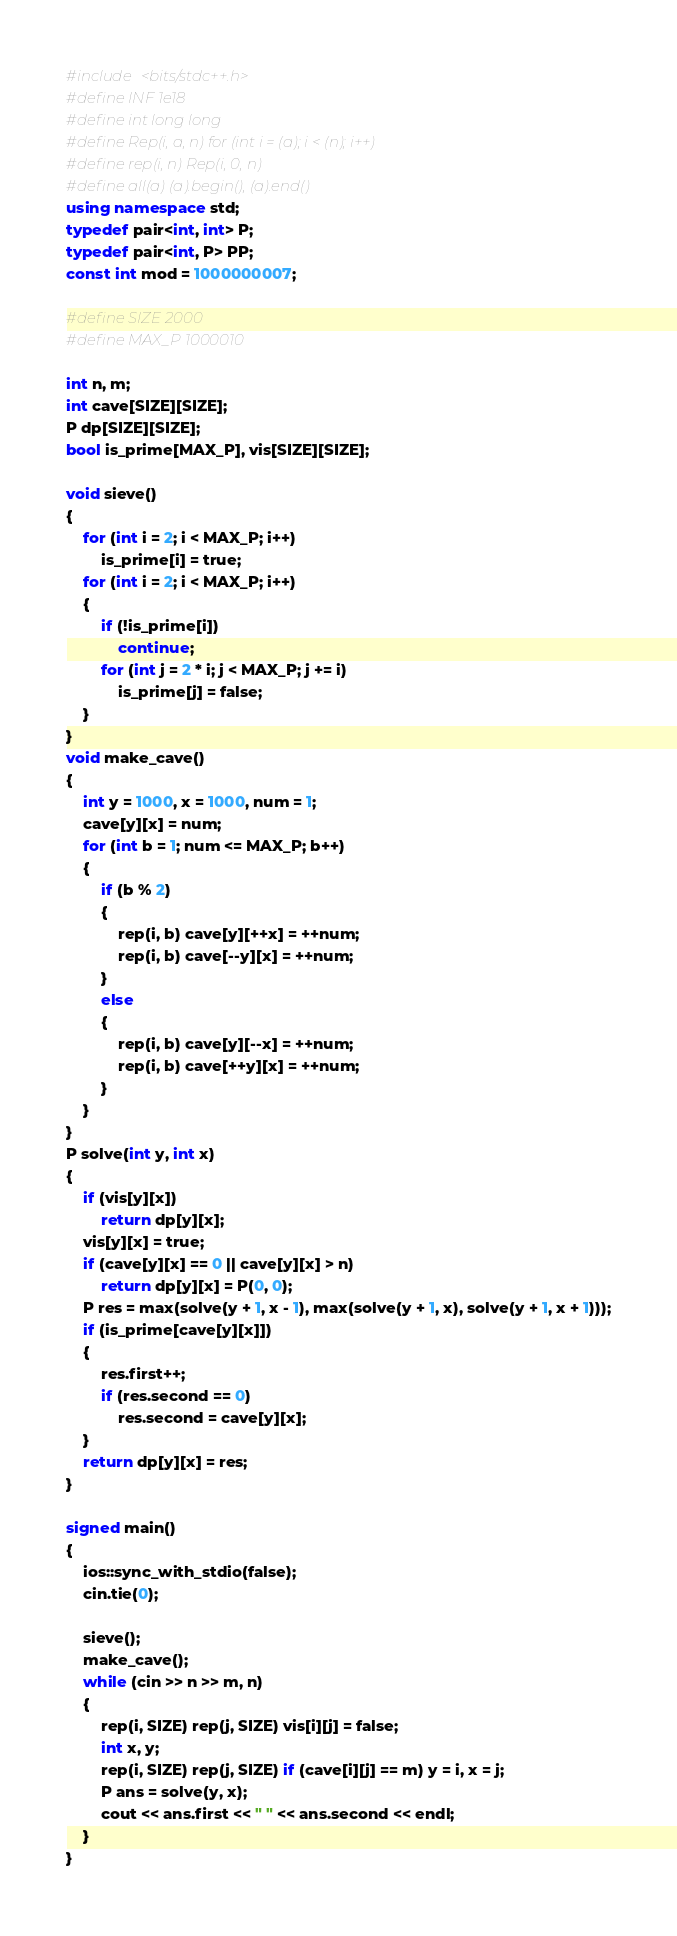Convert code to text. <code><loc_0><loc_0><loc_500><loc_500><_C++_>#include <bits/stdc++.h>
#define INF 1e18
#define int long long
#define Rep(i, a, n) for (int i = (a); i < (n); i++)
#define rep(i, n) Rep(i, 0, n)
#define all(a) (a).begin(), (a).end()
using namespace std;
typedef pair<int, int> P;
typedef pair<int, P> PP;
const int mod = 1000000007;

#define SIZE 2000
#define MAX_P 1000010

int n, m;
int cave[SIZE][SIZE];
P dp[SIZE][SIZE];
bool is_prime[MAX_P], vis[SIZE][SIZE];

void sieve()
{
    for (int i = 2; i < MAX_P; i++)
        is_prime[i] = true;
    for (int i = 2; i < MAX_P; i++)
    {
        if (!is_prime[i])
            continue;
        for (int j = 2 * i; j < MAX_P; j += i)
            is_prime[j] = false;
    }
}
void make_cave()
{
    int y = 1000, x = 1000, num = 1;
    cave[y][x] = num;
    for (int b = 1; num <= MAX_P; b++)
    {
        if (b % 2)
        {
            rep(i, b) cave[y][++x] = ++num;
            rep(i, b) cave[--y][x] = ++num;
        }
        else
        {
            rep(i, b) cave[y][--x] = ++num;
            rep(i, b) cave[++y][x] = ++num;
        }
    }
}
P solve(int y, int x)
{
    if (vis[y][x])
        return dp[y][x];
    vis[y][x] = true;
    if (cave[y][x] == 0 || cave[y][x] > n)
        return dp[y][x] = P(0, 0);
    P res = max(solve(y + 1, x - 1), max(solve(y + 1, x), solve(y + 1, x + 1)));
    if (is_prime[cave[y][x]])
    {
        res.first++;
        if (res.second == 0)
            res.second = cave[y][x];
    }
    return dp[y][x] = res;
}

signed main()
{
    ios::sync_with_stdio(false);
    cin.tie(0);

    sieve();
    make_cave();
    while (cin >> n >> m, n)
    {
        rep(i, SIZE) rep(j, SIZE) vis[i][j] = false;
        int x, y;
        rep(i, SIZE) rep(j, SIZE) if (cave[i][j] == m) y = i, x = j;
        P ans = solve(y, x);
        cout << ans.first << " " << ans.second << endl;
    }
}
</code> 